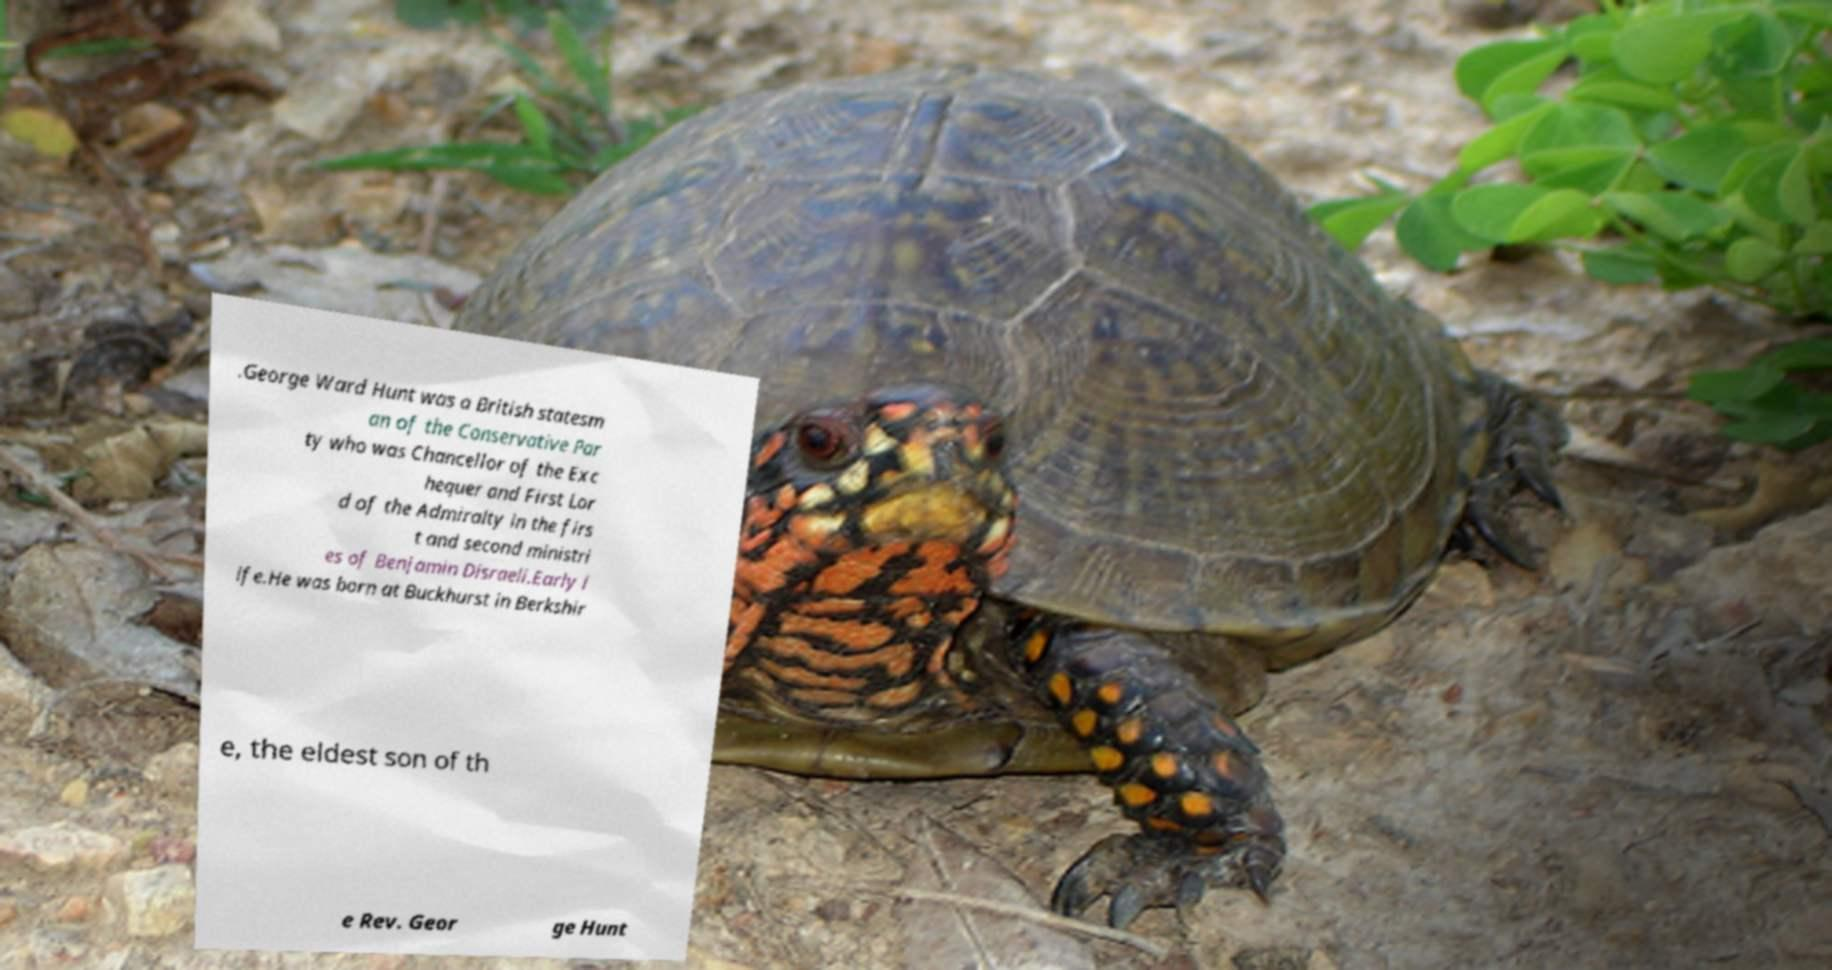Please identify and transcribe the text found in this image. .George Ward Hunt was a British statesm an of the Conservative Par ty who was Chancellor of the Exc hequer and First Lor d of the Admiralty in the firs t and second ministri es of Benjamin Disraeli.Early l ife.He was born at Buckhurst in Berkshir e, the eldest son of th e Rev. Geor ge Hunt 